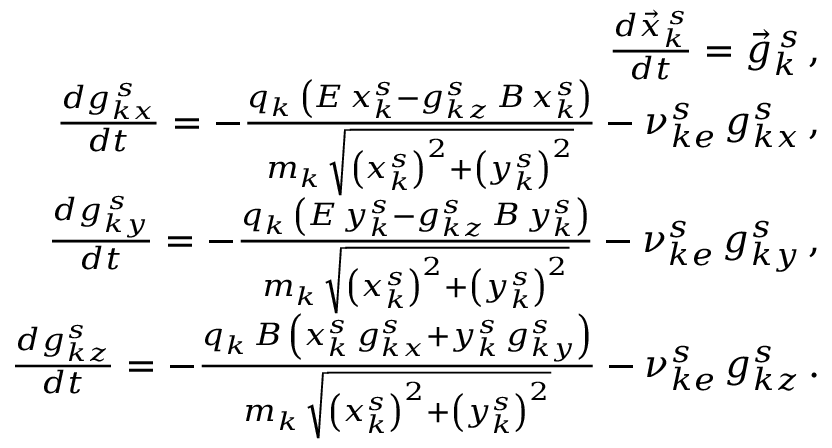<formula> <loc_0><loc_0><loc_500><loc_500>\begin{array} { r l r } & { \frac { d \vec { x } _ { k } ^ { \, s } } { d t } = \vec { g } _ { k } ^ { \, s } \, , } \\ & { \frac { d g _ { k x } ^ { \, s } } { d t } = - \frac { q _ { k } \, \left ( E \, x _ { k } ^ { s } - g _ { k z } ^ { s } \, B \, x _ { k } ^ { s } \right ) } { m _ { k } \, \sqrt { \left ( x _ { k } ^ { s } \right ) ^ { 2 } + \left ( y _ { k } ^ { s } \right ) ^ { 2 } } } - \nu _ { k e } ^ { s } \, g _ { k x } ^ { s } \, , } \\ & { \frac { d g _ { k y } ^ { \, s } } { d t } = - \frac { q _ { k } \, \left ( E \, y _ { k } ^ { s } - g _ { k z } ^ { s } \, B \, y _ { k } ^ { s } \right ) } { m _ { k } \, \sqrt { \left ( x _ { k } ^ { s } \right ) ^ { 2 } + \left ( y _ { k } ^ { s } \right ) ^ { 2 } } } - \nu _ { k e } ^ { s } \, g _ { k y } ^ { s } \, , } \\ & { \frac { d g _ { k z } ^ { s } } { d t } = - \frac { q _ { k } \, B \, \left ( x _ { k } ^ { s } \, g _ { k x } ^ { s } + y _ { k } ^ { s } \, g _ { k y } ^ { s } \right ) } { m _ { k } \, \sqrt { \left ( x _ { k } ^ { s } \right ) ^ { 2 } + \left ( y _ { k } ^ { s } \right ) ^ { 2 } } } - \nu _ { k e } ^ { s } \, g _ { k z } ^ { s } \, . } \end{array}</formula> 